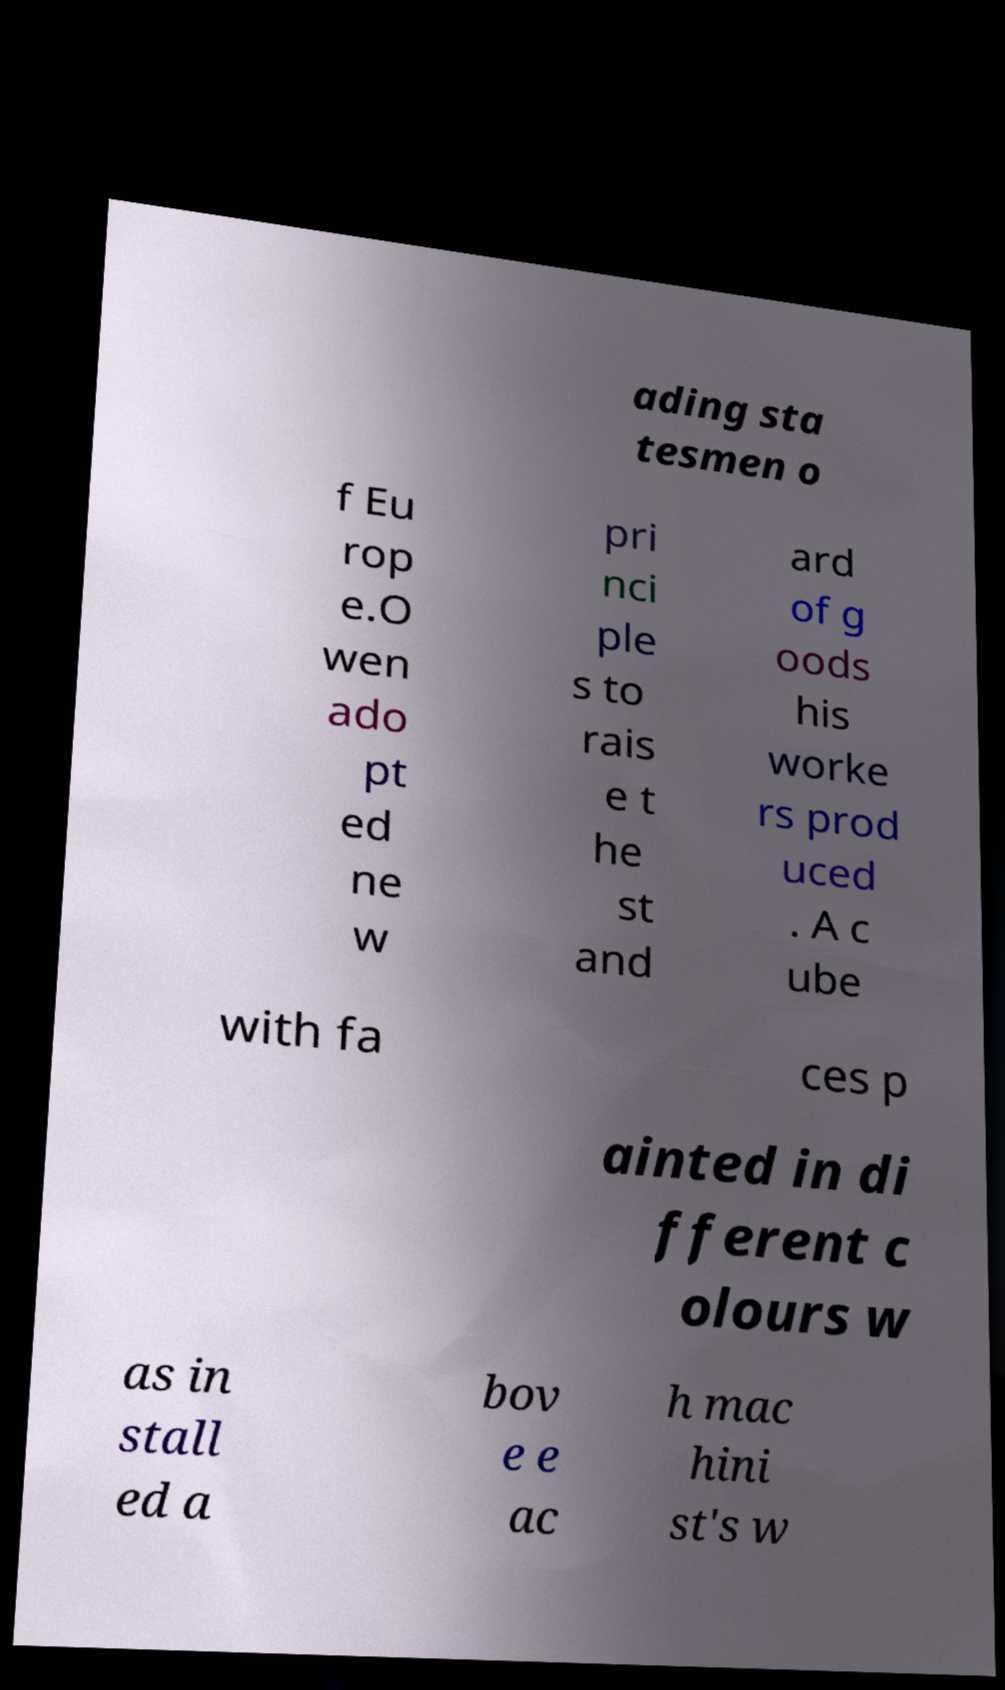Could you assist in decoding the text presented in this image and type it out clearly? ading sta tesmen o f Eu rop e.O wen ado pt ed ne w pri nci ple s to rais e t he st and ard of g oods his worke rs prod uced . A c ube with fa ces p ainted in di fferent c olours w as in stall ed a bov e e ac h mac hini st's w 